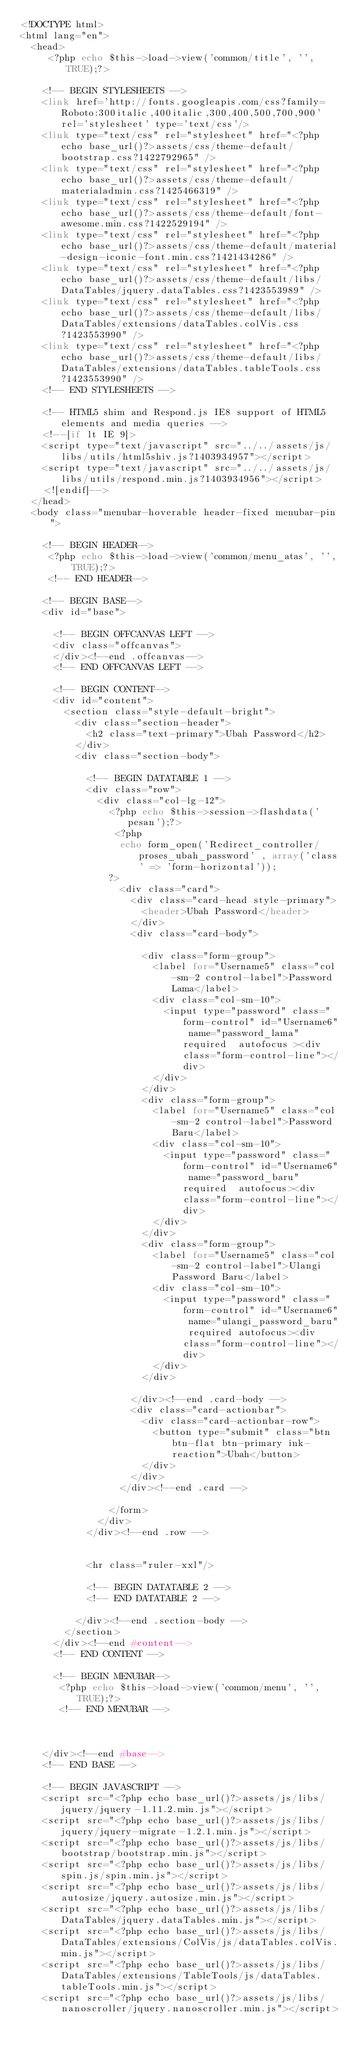Convert code to text. <code><loc_0><loc_0><loc_500><loc_500><_PHP_><!DOCTYPE html>
<html lang="en">
	<head>
		 <?php echo $this->load->view('common/title', '', TRUE);?>

		<!-- BEGIN STYLESHEETS -->
		<link href='http://fonts.googleapis.com/css?family=Roboto:300italic,400italic,300,400,500,700,900' rel='stylesheet' type='text/css'/>
		<link type="text/css" rel="stylesheet" href="<?php echo base_url()?>assets/css/theme-default/bootstrap.css?1422792965" />
		<link type="text/css" rel="stylesheet" href="<?php echo base_url()?>assets/css/theme-default/materialadmin.css?1425466319" />
		<link type="text/css" rel="stylesheet" href="<?php echo base_url()?>assets/css/theme-default/font-awesome.min.css?1422529194" />
		<link type="text/css" rel="stylesheet" href="<?php echo base_url()?>assets/css/theme-default/material-design-iconic-font.min.css?1421434286" />
		<link type="text/css" rel="stylesheet" href="<?php echo base_url()?>assets/css/theme-default/libs/DataTables/jquery.dataTables.css?1423553989" />
		<link type="text/css" rel="stylesheet" href="<?php echo base_url()?>assets/css/theme-default/libs/DataTables/extensions/dataTables.colVis.css?1423553990" />
		<link type="text/css" rel="stylesheet" href="<?php echo base_url()?>assets/css/theme-default/libs/DataTables/extensions/dataTables.tableTools.css?1423553990" />
		<!-- END STYLESHEETS -->

		<!-- HTML5 shim and Respond.js IE8 support of HTML5 elements and media queries -->
		<!--[if lt IE 9]>
		<script type="text/javascript" src="../../assets/js/libs/utils/html5shiv.js?1403934957"></script>
		<script type="text/javascript" src="../../assets/js/libs/utils/respond.min.js?1403934956"></script>
		<![endif]-->
	</head>
	<body class="menubar-hoverable header-fixed menubar-pin">

		<!-- BEGIN HEADER-->
		 <?php echo $this->load->view('common/menu_atas', '', TRUE);?>
		 <!-- END HEADER-->

		<!-- BEGIN BASE-->
		<div id="base">

			<!-- BEGIN OFFCANVAS LEFT -->
			<div class="offcanvas">
			</div><!--end .offcanvas-->
			<!-- END OFFCANVAS LEFT -->

			<!-- BEGIN CONTENT-->
			<div id="content">
				<section class="style-default-bright">
					<div class="section-header">
						<h2 class="text-primary">Ubah Password</h2>
					</div>
					<div class="section-body">

						<!-- BEGIN DATATABLE 1 -->
						<div class="row">
							<div class="col-lg-12">
								<?php echo $this->session->flashdata('pesan');?>
								 <?php
									echo form_open('Redirect_controller/proses_ubah_password' , array('class' => 'form-horizontal'));    
								?>
									<div class="card">
										<div class="card-head style-primary">
											<header>Ubah Password</header>
										</div>
										<div class="card-body">
											
											<div class="form-group">
												<label for="Username5" class="col-sm-2 control-label">Password Lama</label>
												<div class="col-sm-10">
													<input type="password" class="form-control" id="Username6" name="password_lama" required	autofocus	><div class="form-control-line"></div>
												</div>
											</div>
											<div class="form-group">
												<label for="Username5" class="col-sm-2 control-label">Password Baru</label>
												<div class="col-sm-10">
													<input type="password" class="form-control" id="Username6" name="password_baru" required	autofocus><div class="form-control-line"></div>
												</div>
											</div>
											<div class="form-group">
												<label for="Username5" class="col-sm-2 control-label">Ulangi Password Baru</label>
												<div class="col-sm-10">
													<input type="password" class="form-control" id="Username6" name="ulangi_password_baru" required	autofocus><div class="form-control-line"></div>
												</div>
											</div>
											
										</div><!--end .card-body -->
										<div class="card-actionbar">
											<div class="card-actionbar-row">
												<button type="submit" class="btn btn-flat btn-primary ink-reaction">Ubah</button>
											</div>
										</div>
									</div><!--end .card -->
									
								</form>
							</div>
						</div><!--end .row -->
						

						<hr class="ruler-xxl"/>

						<!-- BEGIN DATATABLE 2 -->
						<!-- END DATATABLE 2 -->

					</div><!--end .section-body -->
				</section>
			</div><!--end #content-->
			<!-- END CONTENT -->

			<!-- BEGIN MENUBAR-->
			 <?php echo $this->load->view('common/menu', '', TRUE);?>
			 <!-- END MENUBAR -->

			

		</div><!--end #base-->
		<!-- END BASE -->

		<!-- BEGIN JAVASCRIPT -->
		<script src="<?php echo base_url()?>assets/js/libs/jquery/jquery-1.11.2.min.js"></script>
		<script src="<?php echo base_url()?>assets/js/libs/jquery/jquery-migrate-1.2.1.min.js"></script>
		<script src="<?php echo base_url()?>assets/js/libs/bootstrap/bootstrap.min.js"></script>
		<script src="<?php echo base_url()?>assets/js/libs/spin.js/spin.min.js"></script>
		<script src="<?php echo base_url()?>assets/js/libs/autosize/jquery.autosize.min.js"></script>
		<script src="<?php echo base_url()?>assets/js/libs/DataTables/jquery.dataTables.min.js"></script>
		<script src="<?php echo base_url()?>assets/js/libs/DataTables/extensions/ColVis/js/dataTables.colVis.min.js"></script>
		<script src="<?php echo base_url()?>assets/js/libs/DataTables/extensions/TableTools/js/dataTables.tableTools.min.js"></script>
		<script src="<?php echo base_url()?>assets/js/libs/nanoscroller/jquery.nanoscroller.min.js"></script></code> 